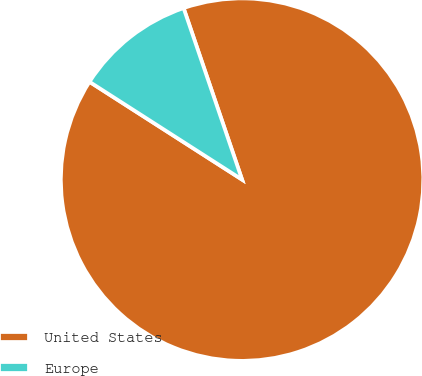Convert chart. <chart><loc_0><loc_0><loc_500><loc_500><pie_chart><fcel>United States<fcel>Europe<nl><fcel>89.3%<fcel>10.7%<nl></chart> 